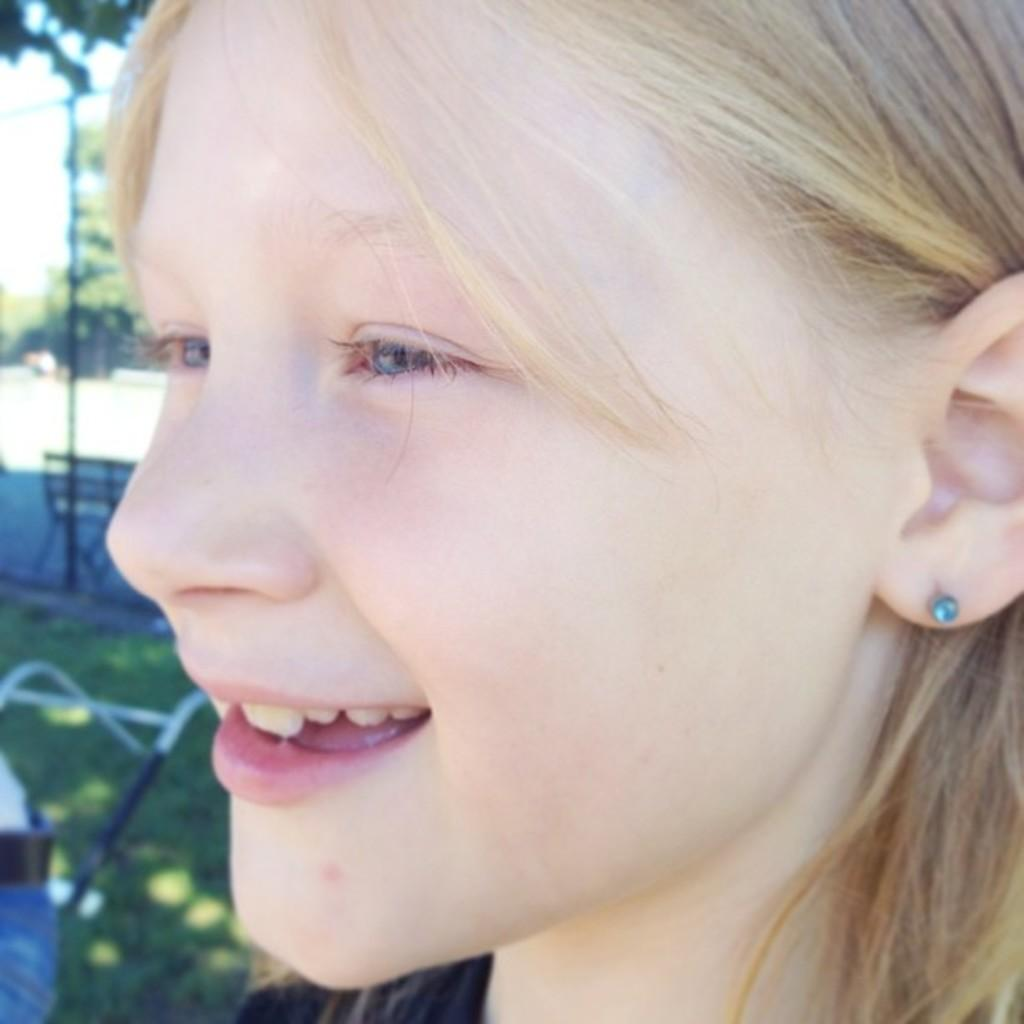Who is present in the image? There is a girl in the image. What is the girl's expression in the image? The girl is smiling in the image. Can you describe any accessories the girl is wearing? The girl is wearing an ear stud in the image. What can be seen in the background of the image? There is grass and a bench in the background of the image. How would you describe the quality of the image? The image is blurred. What type of polish is the girl applying to her nails in the image? There is no indication in the image that the girl is applying any polish to her nails. What kind of plastic material can be seen in the image? There is no plastic material visible in the image. 